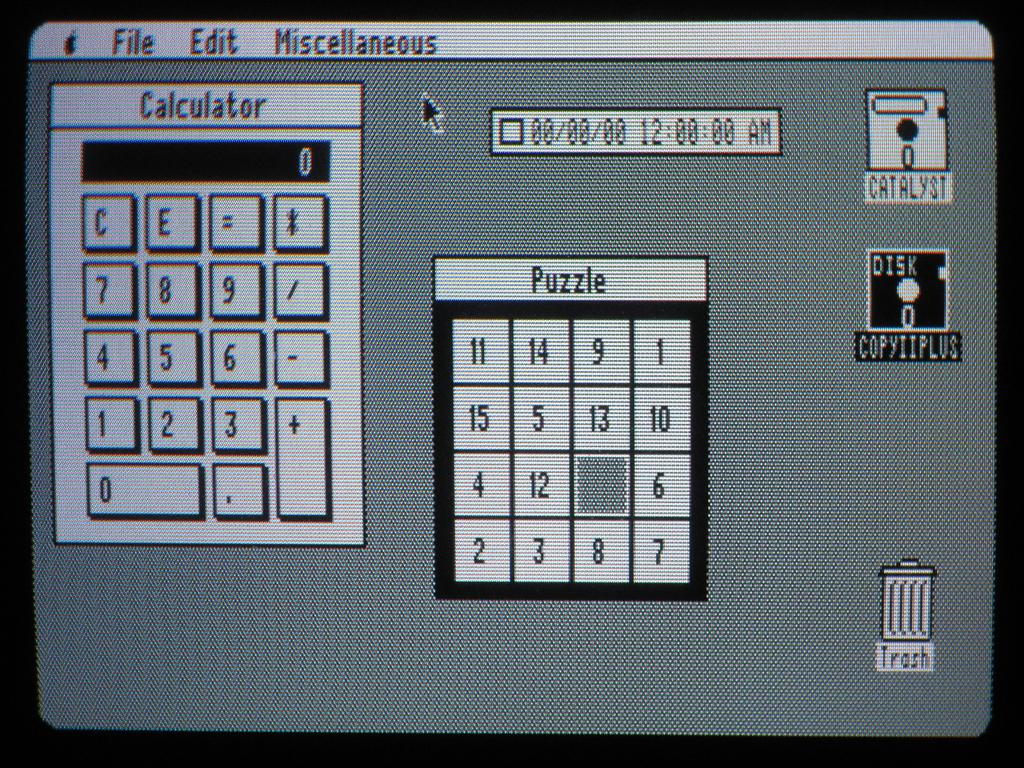What is the third tab on the top of the screen?
Your answer should be very brief. Miscellaneous. 